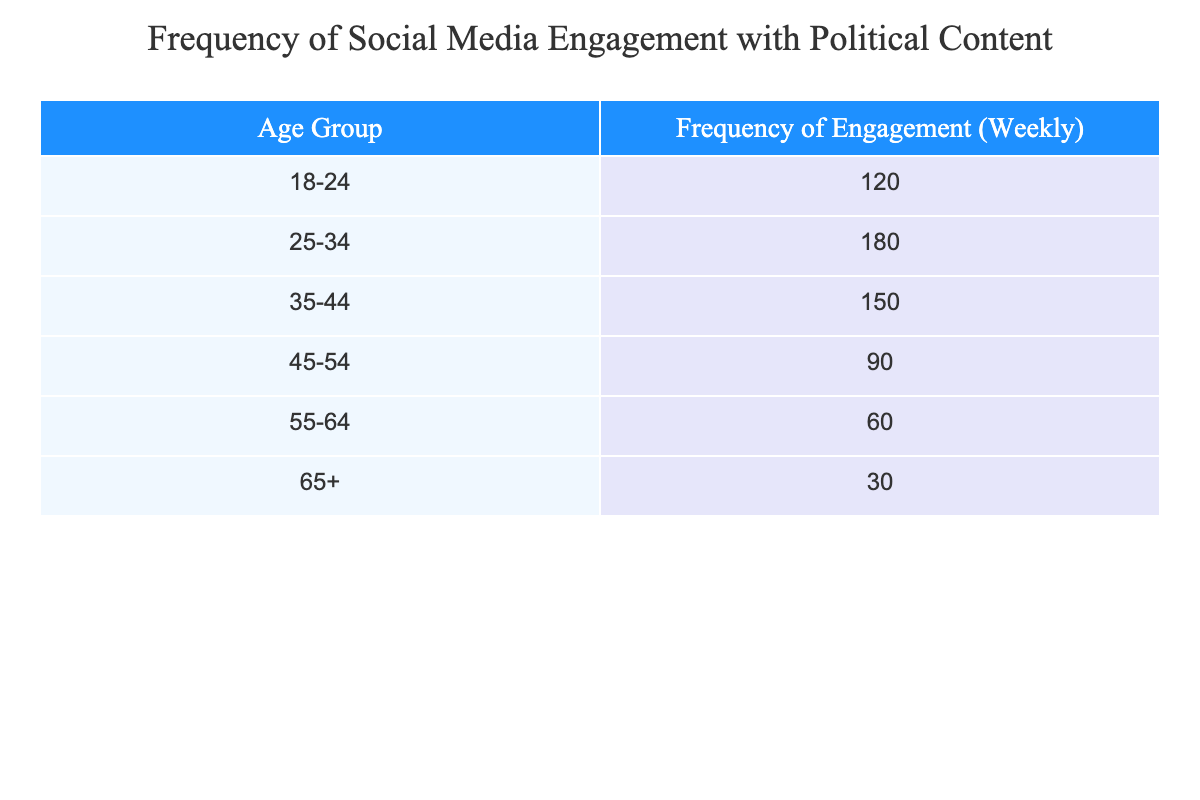What is the frequency of engagement for the age group 25-34? The table shows a direct value for the age group 25-34. By looking at the frequency column corresponding to this age group, we see that the frequency of engagement is 180.
Answer: 180 Which age group has the lowest frequency of engagement? By comparing the frequencies in each row, we can observe that the age group 65+ has the lowest frequency, which is 30.
Answer: 65+ What is the total frequency of engagement for all age groups combined? To find the total, we sum up all the frequencies: 120 + 180 + 150 + 90 + 60 + 30 = 630. Therefore, the total frequency of engagement is 630.
Answer: 630 Is there a significant drop in engagement frequency from the age group 45-54 to 55-64? Looking at the frequencies, the age group 45-54 has a frequency of 90, and the group 55-64 has a frequency of 60. The drop is 30, so we can conclude there is a notable decrease.
Answer: Yes What is the average frequency of engagement across all age groups? We first calculate the total frequency, which is 630. Then we divide this by the number of age groups, which is 6: 630 / 6 = 105. Thus, the average frequency is 105.
Answer: 105 How many age groups have a frequency of engagement higher than 100? Examining the table, the age groups with frequencies 120, 180, and 150 are all higher than 100. This totals to 3 age groups.
Answer: 3 What is the difference in engagement frequency between the 18-24 age group and the 55-64 age group? The frequency for the 18-24 age group is 120, while for the 55-64 age group it is 60. The difference is 120 - 60 = 60.
Answer: 60 Are people aged 35-44 more engaged on social media with political content than those aged 45-54? The engagement frequency for ages 35-44 is 150, and for ages 45-54, it is 90. Since 150 is greater than 90, it confirms the statement.
Answer: Yes 